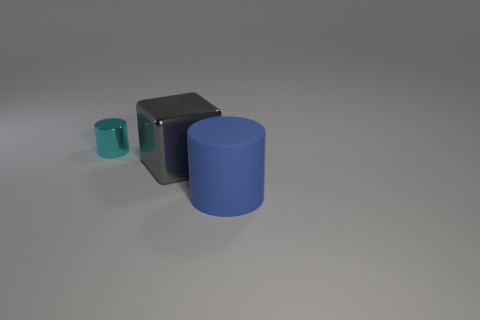The tiny cylinder has what color? cyan 